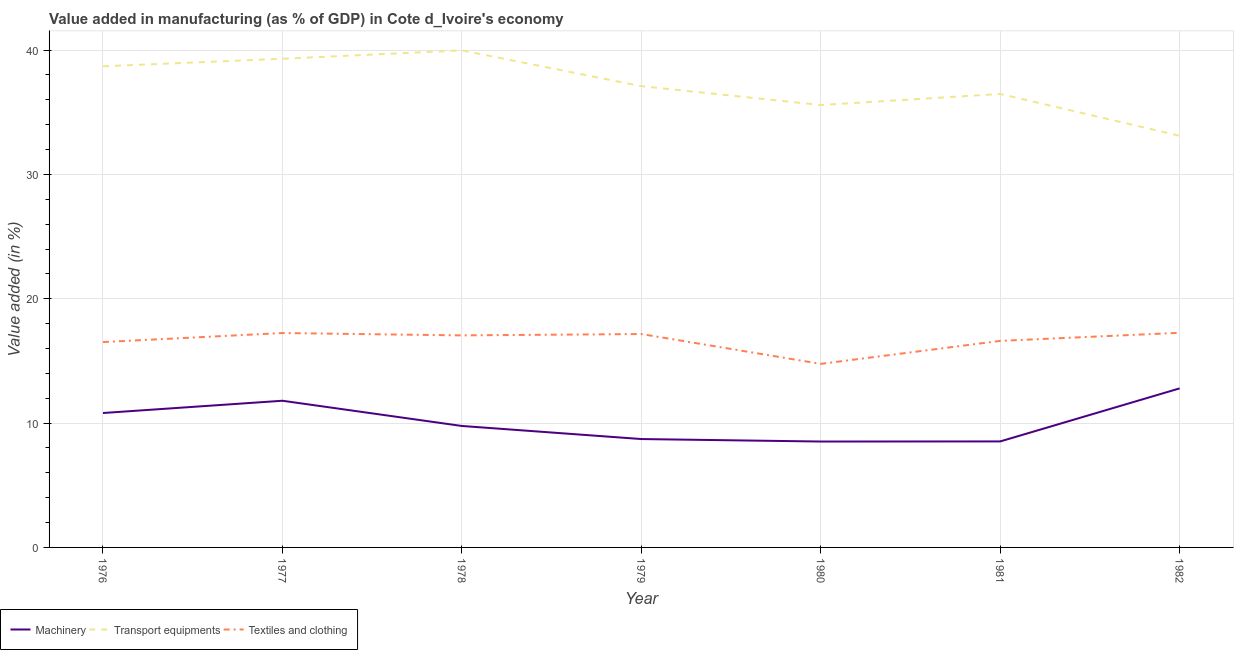Is the number of lines equal to the number of legend labels?
Give a very brief answer. Yes. What is the value added in manufacturing textile and clothing in 1982?
Your answer should be very brief. 17.26. Across all years, what is the maximum value added in manufacturing textile and clothing?
Provide a short and direct response. 17.26. Across all years, what is the minimum value added in manufacturing textile and clothing?
Your answer should be compact. 14.76. In which year was the value added in manufacturing transport equipments maximum?
Provide a short and direct response. 1978. What is the total value added in manufacturing textile and clothing in the graph?
Offer a terse response. 116.62. What is the difference between the value added in manufacturing textile and clothing in 1977 and that in 1978?
Provide a short and direct response. 0.19. What is the difference between the value added in manufacturing transport equipments in 1979 and the value added in manufacturing machinery in 1978?
Your answer should be very brief. 27.33. What is the average value added in manufacturing transport equipments per year?
Offer a very short reply. 37.18. In the year 1979, what is the difference between the value added in manufacturing machinery and value added in manufacturing textile and clothing?
Keep it short and to the point. -8.45. In how many years, is the value added in manufacturing machinery greater than 38 %?
Offer a terse response. 0. What is the ratio of the value added in manufacturing machinery in 1978 to that in 1981?
Provide a short and direct response. 1.15. Is the value added in manufacturing machinery in 1978 less than that in 1980?
Give a very brief answer. No. Is the difference between the value added in manufacturing textile and clothing in 1980 and 1982 greater than the difference between the value added in manufacturing machinery in 1980 and 1982?
Provide a succinct answer. Yes. What is the difference between the highest and the second highest value added in manufacturing machinery?
Your answer should be very brief. 1. What is the difference between the highest and the lowest value added in manufacturing machinery?
Provide a short and direct response. 4.28. In how many years, is the value added in manufacturing transport equipments greater than the average value added in manufacturing transport equipments taken over all years?
Your response must be concise. 3. Is it the case that in every year, the sum of the value added in manufacturing machinery and value added in manufacturing transport equipments is greater than the value added in manufacturing textile and clothing?
Make the answer very short. Yes. Is the value added in manufacturing machinery strictly less than the value added in manufacturing textile and clothing over the years?
Keep it short and to the point. Yes. How many lines are there?
Offer a very short reply. 3. How many years are there in the graph?
Your response must be concise. 7. What is the difference between two consecutive major ticks on the Y-axis?
Keep it short and to the point. 10. Are the values on the major ticks of Y-axis written in scientific E-notation?
Provide a short and direct response. No. Does the graph contain any zero values?
Provide a short and direct response. No. Does the graph contain grids?
Your answer should be compact. Yes. Where does the legend appear in the graph?
Your answer should be compact. Bottom left. How are the legend labels stacked?
Provide a succinct answer. Horizontal. What is the title of the graph?
Give a very brief answer. Value added in manufacturing (as % of GDP) in Cote d_Ivoire's economy. Does "Tertiary" appear as one of the legend labels in the graph?
Give a very brief answer. No. What is the label or title of the Y-axis?
Offer a terse response. Value added (in %). What is the Value added (in %) of Machinery in 1976?
Offer a very short reply. 10.81. What is the Value added (in %) of Transport equipments in 1976?
Give a very brief answer. 38.7. What is the Value added (in %) of Textiles and clothing in 1976?
Ensure brevity in your answer.  16.52. What is the Value added (in %) in Machinery in 1977?
Offer a terse response. 11.8. What is the Value added (in %) of Transport equipments in 1977?
Your answer should be compact. 39.31. What is the Value added (in %) of Textiles and clothing in 1977?
Your answer should be compact. 17.25. What is the Value added (in %) in Machinery in 1978?
Offer a very short reply. 9.77. What is the Value added (in %) of Transport equipments in 1978?
Ensure brevity in your answer.  39.98. What is the Value added (in %) in Textiles and clothing in 1978?
Offer a terse response. 17.05. What is the Value added (in %) in Machinery in 1979?
Offer a terse response. 8.72. What is the Value added (in %) of Transport equipments in 1979?
Your answer should be compact. 37.1. What is the Value added (in %) in Textiles and clothing in 1979?
Give a very brief answer. 17.16. What is the Value added (in %) in Machinery in 1980?
Give a very brief answer. 8.52. What is the Value added (in %) in Transport equipments in 1980?
Offer a very short reply. 35.58. What is the Value added (in %) in Textiles and clothing in 1980?
Keep it short and to the point. 14.76. What is the Value added (in %) in Machinery in 1981?
Your answer should be compact. 8.53. What is the Value added (in %) of Transport equipments in 1981?
Provide a succinct answer. 36.48. What is the Value added (in %) in Textiles and clothing in 1981?
Provide a short and direct response. 16.61. What is the Value added (in %) in Machinery in 1982?
Your answer should be very brief. 12.79. What is the Value added (in %) in Transport equipments in 1982?
Make the answer very short. 33.11. What is the Value added (in %) in Textiles and clothing in 1982?
Provide a succinct answer. 17.26. Across all years, what is the maximum Value added (in %) in Machinery?
Your answer should be compact. 12.79. Across all years, what is the maximum Value added (in %) in Transport equipments?
Keep it short and to the point. 39.98. Across all years, what is the maximum Value added (in %) of Textiles and clothing?
Your response must be concise. 17.26. Across all years, what is the minimum Value added (in %) in Machinery?
Your answer should be compact. 8.52. Across all years, what is the minimum Value added (in %) of Transport equipments?
Provide a short and direct response. 33.11. Across all years, what is the minimum Value added (in %) of Textiles and clothing?
Ensure brevity in your answer.  14.76. What is the total Value added (in %) in Machinery in the graph?
Your response must be concise. 70.93. What is the total Value added (in %) of Transport equipments in the graph?
Offer a terse response. 260.26. What is the total Value added (in %) in Textiles and clothing in the graph?
Provide a short and direct response. 116.62. What is the difference between the Value added (in %) of Machinery in 1976 and that in 1977?
Your answer should be very brief. -0.99. What is the difference between the Value added (in %) of Transport equipments in 1976 and that in 1977?
Your response must be concise. -0.61. What is the difference between the Value added (in %) of Textiles and clothing in 1976 and that in 1977?
Provide a succinct answer. -0.73. What is the difference between the Value added (in %) of Machinery in 1976 and that in 1978?
Your answer should be very brief. 1.04. What is the difference between the Value added (in %) of Transport equipments in 1976 and that in 1978?
Offer a very short reply. -1.28. What is the difference between the Value added (in %) of Textiles and clothing in 1976 and that in 1978?
Provide a short and direct response. -0.54. What is the difference between the Value added (in %) of Machinery in 1976 and that in 1979?
Your response must be concise. 2.09. What is the difference between the Value added (in %) of Transport equipments in 1976 and that in 1979?
Offer a very short reply. 1.6. What is the difference between the Value added (in %) of Textiles and clothing in 1976 and that in 1979?
Make the answer very short. -0.65. What is the difference between the Value added (in %) of Machinery in 1976 and that in 1980?
Make the answer very short. 2.29. What is the difference between the Value added (in %) of Transport equipments in 1976 and that in 1980?
Ensure brevity in your answer.  3.11. What is the difference between the Value added (in %) in Textiles and clothing in 1976 and that in 1980?
Make the answer very short. 1.75. What is the difference between the Value added (in %) of Machinery in 1976 and that in 1981?
Your response must be concise. 2.29. What is the difference between the Value added (in %) in Transport equipments in 1976 and that in 1981?
Give a very brief answer. 2.22. What is the difference between the Value added (in %) in Textiles and clothing in 1976 and that in 1981?
Provide a short and direct response. -0.1. What is the difference between the Value added (in %) of Machinery in 1976 and that in 1982?
Provide a short and direct response. -1.98. What is the difference between the Value added (in %) in Transport equipments in 1976 and that in 1982?
Make the answer very short. 5.59. What is the difference between the Value added (in %) in Textiles and clothing in 1976 and that in 1982?
Your response must be concise. -0.75. What is the difference between the Value added (in %) of Machinery in 1977 and that in 1978?
Provide a succinct answer. 2.03. What is the difference between the Value added (in %) in Transport equipments in 1977 and that in 1978?
Make the answer very short. -0.67. What is the difference between the Value added (in %) of Textiles and clothing in 1977 and that in 1978?
Offer a very short reply. 0.19. What is the difference between the Value added (in %) in Machinery in 1977 and that in 1979?
Your answer should be compact. 3.08. What is the difference between the Value added (in %) of Transport equipments in 1977 and that in 1979?
Provide a succinct answer. 2.2. What is the difference between the Value added (in %) in Textiles and clothing in 1977 and that in 1979?
Ensure brevity in your answer.  0.08. What is the difference between the Value added (in %) of Machinery in 1977 and that in 1980?
Make the answer very short. 3.28. What is the difference between the Value added (in %) in Transport equipments in 1977 and that in 1980?
Give a very brief answer. 3.72. What is the difference between the Value added (in %) of Textiles and clothing in 1977 and that in 1980?
Provide a succinct answer. 2.48. What is the difference between the Value added (in %) in Machinery in 1977 and that in 1981?
Your response must be concise. 3.27. What is the difference between the Value added (in %) of Transport equipments in 1977 and that in 1981?
Provide a short and direct response. 2.83. What is the difference between the Value added (in %) in Textiles and clothing in 1977 and that in 1981?
Provide a short and direct response. 0.63. What is the difference between the Value added (in %) of Machinery in 1977 and that in 1982?
Make the answer very short. -1. What is the difference between the Value added (in %) in Transport equipments in 1977 and that in 1982?
Ensure brevity in your answer.  6.2. What is the difference between the Value added (in %) in Textiles and clothing in 1977 and that in 1982?
Provide a succinct answer. -0.02. What is the difference between the Value added (in %) of Machinery in 1978 and that in 1979?
Keep it short and to the point. 1.05. What is the difference between the Value added (in %) in Transport equipments in 1978 and that in 1979?
Your answer should be compact. 2.88. What is the difference between the Value added (in %) in Textiles and clothing in 1978 and that in 1979?
Make the answer very short. -0.11. What is the difference between the Value added (in %) of Machinery in 1978 and that in 1980?
Ensure brevity in your answer.  1.25. What is the difference between the Value added (in %) of Transport equipments in 1978 and that in 1980?
Your response must be concise. 4.39. What is the difference between the Value added (in %) of Textiles and clothing in 1978 and that in 1980?
Offer a very short reply. 2.29. What is the difference between the Value added (in %) in Machinery in 1978 and that in 1981?
Keep it short and to the point. 1.24. What is the difference between the Value added (in %) of Transport equipments in 1978 and that in 1981?
Offer a terse response. 3.5. What is the difference between the Value added (in %) in Textiles and clothing in 1978 and that in 1981?
Provide a succinct answer. 0.44. What is the difference between the Value added (in %) of Machinery in 1978 and that in 1982?
Your answer should be compact. -3.02. What is the difference between the Value added (in %) of Transport equipments in 1978 and that in 1982?
Provide a succinct answer. 6.87. What is the difference between the Value added (in %) of Textiles and clothing in 1978 and that in 1982?
Provide a succinct answer. -0.21. What is the difference between the Value added (in %) in Machinery in 1979 and that in 1980?
Provide a succinct answer. 0.2. What is the difference between the Value added (in %) of Transport equipments in 1979 and that in 1980?
Offer a very short reply. 1.52. What is the difference between the Value added (in %) of Textiles and clothing in 1979 and that in 1980?
Keep it short and to the point. 2.4. What is the difference between the Value added (in %) in Machinery in 1979 and that in 1981?
Give a very brief answer. 0.19. What is the difference between the Value added (in %) in Transport equipments in 1979 and that in 1981?
Your answer should be compact. 0.63. What is the difference between the Value added (in %) of Textiles and clothing in 1979 and that in 1981?
Make the answer very short. 0.55. What is the difference between the Value added (in %) in Machinery in 1979 and that in 1982?
Your answer should be compact. -4.08. What is the difference between the Value added (in %) of Transport equipments in 1979 and that in 1982?
Provide a succinct answer. 3.99. What is the difference between the Value added (in %) in Textiles and clothing in 1979 and that in 1982?
Give a very brief answer. -0.1. What is the difference between the Value added (in %) of Machinery in 1980 and that in 1981?
Offer a very short reply. -0.01. What is the difference between the Value added (in %) of Transport equipments in 1980 and that in 1981?
Make the answer very short. -0.89. What is the difference between the Value added (in %) in Textiles and clothing in 1980 and that in 1981?
Give a very brief answer. -1.85. What is the difference between the Value added (in %) in Machinery in 1980 and that in 1982?
Your response must be concise. -4.28. What is the difference between the Value added (in %) in Transport equipments in 1980 and that in 1982?
Offer a very short reply. 2.47. What is the difference between the Value added (in %) in Textiles and clothing in 1980 and that in 1982?
Provide a short and direct response. -2.5. What is the difference between the Value added (in %) of Machinery in 1981 and that in 1982?
Offer a terse response. -4.27. What is the difference between the Value added (in %) in Transport equipments in 1981 and that in 1982?
Your answer should be compact. 3.36. What is the difference between the Value added (in %) of Textiles and clothing in 1981 and that in 1982?
Make the answer very short. -0.65. What is the difference between the Value added (in %) in Machinery in 1976 and the Value added (in %) in Transport equipments in 1977?
Make the answer very short. -28.49. What is the difference between the Value added (in %) in Machinery in 1976 and the Value added (in %) in Textiles and clothing in 1977?
Ensure brevity in your answer.  -6.43. What is the difference between the Value added (in %) in Transport equipments in 1976 and the Value added (in %) in Textiles and clothing in 1977?
Keep it short and to the point. 21.45. What is the difference between the Value added (in %) in Machinery in 1976 and the Value added (in %) in Transport equipments in 1978?
Give a very brief answer. -29.17. What is the difference between the Value added (in %) of Machinery in 1976 and the Value added (in %) of Textiles and clothing in 1978?
Offer a very short reply. -6.24. What is the difference between the Value added (in %) of Transport equipments in 1976 and the Value added (in %) of Textiles and clothing in 1978?
Offer a very short reply. 21.64. What is the difference between the Value added (in %) of Machinery in 1976 and the Value added (in %) of Transport equipments in 1979?
Your answer should be very brief. -26.29. What is the difference between the Value added (in %) in Machinery in 1976 and the Value added (in %) in Textiles and clothing in 1979?
Your answer should be compact. -6.35. What is the difference between the Value added (in %) in Transport equipments in 1976 and the Value added (in %) in Textiles and clothing in 1979?
Provide a short and direct response. 21.54. What is the difference between the Value added (in %) of Machinery in 1976 and the Value added (in %) of Transport equipments in 1980?
Keep it short and to the point. -24.77. What is the difference between the Value added (in %) in Machinery in 1976 and the Value added (in %) in Textiles and clothing in 1980?
Offer a very short reply. -3.95. What is the difference between the Value added (in %) of Transport equipments in 1976 and the Value added (in %) of Textiles and clothing in 1980?
Ensure brevity in your answer.  23.94. What is the difference between the Value added (in %) of Machinery in 1976 and the Value added (in %) of Transport equipments in 1981?
Offer a terse response. -25.66. What is the difference between the Value added (in %) in Machinery in 1976 and the Value added (in %) in Textiles and clothing in 1981?
Keep it short and to the point. -5.8. What is the difference between the Value added (in %) of Transport equipments in 1976 and the Value added (in %) of Textiles and clothing in 1981?
Your answer should be compact. 22.09. What is the difference between the Value added (in %) in Machinery in 1976 and the Value added (in %) in Transport equipments in 1982?
Your response must be concise. -22.3. What is the difference between the Value added (in %) in Machinery in 1976 and the Value added (in %) in Textiles and clothing in 1982?
Make the answer very short. -6.45. What is the difference between the Value added (in %) of Transport equipments in 1976 and the Value added (in %) of Textiles and clothing in 1982?
Provide a succinct answer. 21.44. What is the difference between the Value added (in %) of Machinery in 1977 and the Value added (in %) of Transport equipments in 1978?
Provide a short and direct response. -28.18. What is the difference between the Value added (in %) in Machinery in 1977 and the Value added (in %) in Textiles and clothing in 1978?
Offer a terse response. -5.26. What is the difference between the Value added (in %) of Transport equipments in 1977 and the Value added (in %) of Textiles and clothing in 1978?
Your answer should be very brief. 22.25. What is the difference between the Value added (in %) of Machinery in 1977 and the Value added (in %) of Transport equipments in 1979?
Your response must be concise. -25.31. What is the difference between the Value added (in %) in Machinery in 1977 and the Value added (in %) in Textiles and clothing in 1979?
Keep it short and to the point. -5.37. What is the difference between the Value added (in %) of Transport equipments in 1977 and the Value added (in %) of Textiles and clothing in 1979?
Make the answer very short. 22.14. What is the difference between the Value added (in %) of Machinery in 1977 and the Value added (in %) of Transport equipments in 1980?
Make the answer very short. -23.79. What is the difference between the Value added (in %) of Machinery in 1977 and the Value added (in %) of Textiles and clothing in 1980?
Provide a short and direct response. -2.97. What is the difference between the Value added (in %) in Transport equipments in 1977 and the Value added (in %) in Textiles and clothing in 1980?
Keep it short and to the point. 24.54. What is the difference between the Value added (in %) in Machinery in 1977 and the Value added (in %) in Transport equipments in 1981?
Your answer should be very brief. -24.68. What is the difference between the Value added (in %) of Machinery in 1977 and the Value added (in %) of Textiles and clothing in 1981?
Give a very brief answer. -4.82. What is the difference between the Value added (in %) of Transport equipments in 1977 and the Value added (in %) of Textiles and clothing in 1981?
Your answer should be very brief. 22.69. What is the difference between the Value added (in %) in Machinery in 1977 and the Value added (in %) in Transport equipments in 1982?
Your answer should be compact. -21.31. What is the difference between the Value added (in %) of Machinery in 1977 and the Value added (in %) of Textiles and clothing in 1982?
Offer a terse response. -5.47. What is the difference between the Value added (in %) of Transport equipments in 1977 and the Value added (in %) of Textiles and clothing in 1982?
Provide a succinct answer. 22.04. What is the difference between the Value added (in %) of Machinery in 1978 and the Value added (in %) of Transport equipments in 1979?
Your answer should be very brief. -27.33. What is the difference between the Value added (in %) in Machinery in 1978 and the Value added (in %) in Textiles and clothing in 1979?
Ensure brevity in your answer.  -7.39. What is the difference between the Value added (in %) of Transport equipments in 1978 and the Value added (in %) of Textiles and clothing in 1979?
Your answer should be very brief. 22.82. What is the difference between the Value added (in %) in Machinery in 1978 and the Value added (in %) in Transport equipments in 1980?
Ensure brevity in your answer.  -25.82. What is the difference between the Value added (in %) of Machinery in 1978 and the Value added (in %) of Textiles and clothing in 1980?
Offer a terse response. -4.99. What is the difference between the Value added (in %) in Transport equipments in 1978 and the Value added (in %) in Textiles and clothing in 1980?
Your response must be concise. 25.22. What is the difference between the Value added (in %) of Machinery in 1978 and the Value added (in %) of Transport equipments in 1981?
Offer a terse response. -26.71. What is the difference between the Value added (in %) of Machinery in 1978 and the Value added (in %) of Textiles and clothing in 1981?
Make the answer very short. -6.84. What is the difference between the Value added (in %) of Transport equipments in 1978 and the Value added (in %) of Textiles and clothing in 1981?
Offer a terse response. 23.37. What is the difference between the Value added (in %) of Machinery in 1978 and the Value added (in %) of Transport equipments in 1982?
Give a very brief answer. -23.34. What is the difference between the Value added (in %) in Machinery in 1978 and the Value added (in %) in Textiles and clothing in 1982?
Offer a terse response. -7.49. What is the difference between the Value added (in %) in Transport equipments in 1978 and the Value added (in %) in Textiles and clothing in 1982?
Provide a short and direct response. 22.72. What is the difference between the Value added (in %) of Machinery in 1979 and the Value added (in %) of Transport equipments in 1980?
Your response must be concise. -26.87. What is the difference between the Value added (in %) of Machinery in 1979 and the Value added (in %) of Textiles and clothing in 1980?
Offer a very short reply. -6.05. What is the difference between the Value added (in %) of Transport equipments in 1979 and the Value added (in %) of Textiles and clothing in 1980?
Offer a terse response. 22.34. What is the difference between the Value added (in %) of Machinery in 1979 and the Value added (in %) of Transport equipments in 1981?
Your response must be concise. -27.76. What is the difference between the Value added (in %) in Machinery in 1979 and the Value added (in %) in Textiles and clothing in 1981?
Keep it short and to the point. -7.9. What is the difference between the Value added (in %) of Transport equipments in 1979 and the Value added (in %) of Textiles and clothing in 1981?
Provide a succinct answer. 20.49. What is the difference between the Value added (in %) of Machinery in 1979 and the Value added (in %) of Transport equipments in 1982?
Your response must be concise. -24.39. What is the difference between the Value added (in %) of Machinery in 1979 and the Value added (in %) of Textiles and clothing in 1982?
Offer a very short reply. -8.55. What is the difference between the Value added (in %) in Transport equipments in 1979 and the Value added (in %) in Textiles and clothing in 1982?
Offer a very short reply. 19.84. What is the difference between the Value added (in %) of Machinery in 1980 and the Value added (in %) of Transport equipments in 1981?
Ensure brevity in your answer.  -27.96. What is the difference between the Value added (in %) of Machinery in 1980 and the Value added (in %) of Textiles and clothing in 1981?
Make the answer very short. -8.1. What is the difference between the Value added (in %) of Transport equipments in 1980 and the Value added (in %) of Textiles and clothing in 1981?
Provide a short and direct response. 18.97. What is the difference between the Value added (in %) in Machinery in 1980 and the Value added (in %) in Transport equipments in 1982?
Ensure brevity in your answer.  -24.59. What is the difference between the Value added (in %) of Machinery in 1980 and the Value added (in %) of Textiles and clothing in 1982?
Make the answer very short. -8.75. What is the difference between the Value added (in %) in Transport equipments in 1980 and the Value added (in %) in Textiles and clothing in 1982?
Make the answer very short. 18.32. What is the difference between the Value added (in %) in Machinery in 1981 and the Value added (in %) in Transport equipments in 1982?
Provide a succinct answer. -24.58. What is the difference between the Value added (in %) in Machinery in 1981 and the Value added (in %) in Textiles and clothing in 1982?
Provide a succinct answer. -8.74. What is the difference between the Value added (in %) of Transport equipments in 1981 and the Value added (in %) of Textiles and clothing in 1982?
Provide a succinct answer. 19.21. What is the average Value added (in %) of Machinery per year?
Give a very brief answer. 10.13. What is the average Value added (in %) of Transport equipments per year?
Provide a short and direct response. 37.18. What is the average Value added (in %) in Textiles and clothing per year?
Offer a very short reply. 16.66. In the year 1976, what is the difference between the Value added (in %) of Machinery and Value added (in %) of Transport equipments?
Give a very brief answer. -27.89. In the year 1976, what is the difference between the Value added (in %) of Machinery and Value added (in %) of Textiles and clothing?
Give a very brief answer. -5.71. In the year 1976, what is the difference between the Value added (in %) of Transport equipments and Value added (in %) of Textiles and clothing?
Provide a succinct answer. 22.18. In the year 1977, what is the difference between the Value added (in %) of Machinery and Value added (in %) of Transport equipments?
Your answer should be compact. -27.51. In the year 1977, what is the difference between the Value added (in %) of Machinery and Value added (in %) of Textiles and clothing?
Your answer should be compact. -5.45. In the year 1977, what is the difference between the Value added (in %) of Transport equipments and Value added (in %) of Textiles and clothing?
Ensure brevity in your answer.  22.06. In the year 1978, what is the difference between the Value added (in %) of Machinery and Value added (in %) of Transport equipments?
Your response must be concise. -30.21. In the year 1978, what is the difference between the Value added (in %) of Machinery and Value added (in %) of Textiles and clothing?
Make the answer very short. -7.29. In the year 1978, what is the difference between the Value added (in %) in Transport equipments and Value added (in %) in Textiles and clothing?
Your response must be concise. 22.92. In the year 1979, what is the difference between the Value added (in %) in Machinery and Value added (in %) in Transport equipments?
Offer a terse response. -28.39. In the year 1979, what is the difference between the Value added (in %) in Machinery and Value added (in %) in Textiles and clothing?
Give a very brief answer. -8.45. In the year 1979, what is the difference between the Value added (in %) of Transport equipments and Value added (in %) of Textiles and clothing?
Provide a succinct answer. 19.94. In the year 1980, what is the difference between the Value added (in %) in Machinery and Value added (in %) in Transport equipments?
Ensure brevity in your answer.  -27.07. In the year 1980, what is the difference between the Value added (in %) of Machinery and Value added (in %) of Textiles and clothing?
Your response must be concise. -6.25. In the year 1980, what is the difference between the Value added (in %) in Transport equipments and Value added (in %) in Textiles and clothing?
Offer a terse response. 20.82. In the year 1981, what is the difference between the Value added (in %) in Machinery and Value added (in %) in Transport equipments?
Make the answer very short. -27.95. In the year 1981, what is the difference between the Value added (in %) of Machinery and Value added (in %) of Textiles and clothing?
Your answer should be very brief. -8.09. In the year 1981, what is the difference between the Value added (in %) in Transport equipments and Value added (in %) in Textiles and clothing?
Your answer should be very brief. 19.86. In the year 1982, what is the difference between the Value added (in %) of Machinery and Value added (in %) of Transport equipments?
Give a very brief answer. -20.32. In the year 1982, what is the difference between the Value added (in %) in Machinery and Value added (in %) in Textiles and clothing?
Keep it short and to the point. -4.47. In the year 1982, what is the difference between the Value added (in %) in Transport equipments and Value added (in %) in Textiles and clothing?
Offer a terse response. 15.85. What is the ratio of the Value added (in %) of Machinery in 1976 to that in 1977?
Your response must be concise. 0.92. What is the ratio of the Value added (in %) in Transport equipments in 1976 to that in 1977?
Ensure brevity in your answer.  0.98. What is the ratio of the Value added (in %) of Textiles and clothing in 1976 to that in 1977?
Your response must be concise. 0.96. What is the ratio of the Value added (in %) in Machinery in 1976 to that in 1978?
Your answer should be compact. 1.11. What is the ratio of the Value added (in %) of Textiles and clothing in 1976 to that in 1978?
Your answer should be compact. 0.97. What is the ratio of the Value added (in %) of Machinery in 1976 to that in 1979?
Ensure brevity in your answer.  1.24. What is the ratio of the Value added (in %) in Transport equipments in 1976 to that in 1979?
Provide a short and direct response. 1.04. What is the ratio of the Value added (in %) of Textiles and clothing in 1976 to that in 1979?
Provide a short and direct response. 0.96. What is the ratio of the Value added (in %) of Machinery in 1976 to that in 1980?
Keep it short and to the point. 1.27. What is the ratio of the Value added (in %) of Transport equipments in 1976 to that in 1980?
Make the answer very short. 1.09. What is the ratio of the Value added (in %) of Textiles and clothing in 1976 to that in 1980?
Provide a succinct answer. 1.12. What is the ratio of the Value added (in %) in Machinery in 1976 to that in 1981?
Your response must be concise. 1.27. What is the ratio of the Value added (in %) of Transport equipments in 1976 to that in 1981?
Ensure brevity in your answer.  1.06. What is the ratio of the Value added (in %) in Machinery in 1976 to that in 1982?
Provide a short and direct response. 0.85. What is the ratio of the Value added (in %) of Transport equipments in 1976 to that in 1982?
Offer a terse response. 1.17. What is the ratio of the Value added (in %) of Textiles and clothing in 1976 to that in 1982?
Keep it short and to the point. 0.96. What is the ratio of the Value added (in %) of Machinery in 1977 to that in 1978?
Ensure brevity in your answer.  1.21. What is the ratio of the Value added (in %) in Transport equipments in 1977 to that in 1978?
Make the answer very short. 0.98. What is the ratio of the Value added (in %) of Textiles and clothing in 1977 to that in 1978?
Make the answer very short. 1.01. What is the ratio of the Value added (in %) in Machinery in 1977 to that in 1979?
Your answer should be compact. 1.35. What is the ratio of the Value added (in %) of Transport equipments in 1977 to that in 1979?
Your answer should be compact. 1.06. What is the ratio of the Value added (in %) in Machinery in 1977 to that in 1980?
Give a very brief answer. 1.39. What is the ratio of the Value added (in %) of Transport equipments in 1977 to that in 1980?
Keep it short and to the point. 1.1. What is the ratio of the Value added (in %) of Textiles and clothing in 1977 to that in 1980?
Make the answer very short. 1.17. What is the ratio of the Value added (in %) of Machinery in 1977 to that in 1981?
Ensure brevity in your answer.  1.38. What is the ratio of the Value added (in %) in Transport equipments in 1977 to that in 1981?
Provide a succinct answer. 1.08. What is the ratio of the Value added (in %) of Textiles and clothing in 1977 to that in 1981?
Make the answer very short. 1.04. What is the ratio of the Value added (in %) of Machinery in 1977 to that in 1982?
Offer a very short reply. 0.92. What is the ratio of the Value added (in %) of Transport equipments in 1977 to that in 1982?
Your response must be concise. 1.19. What is the ratio of the Value added (in %) of Textiles and clothing in 1977 to that in 1982?
Your answer should be very brief. 1. What is the ratio of the Value added (in %) in Machinery in 1978 to that in 1979?
Provide a short and direct response. 1.12. What is the ratio of the Value added (in %) in Transport equipments in 1978 to that in 1979?
Offer a terse response. 1.08. What is the ratio of the Value added (in %) in Machinery in 1978 to that in 1980?
Make the answer very short. 1.15. What is the ratio of the Value added (in %) in Transport equipments in 1978 to that in 1980?
Offer a terse response. 1.12. What is the ratio of the Value added (in %) of Textiles and clothing in 1978 to that in 1980?
Provide a succinct answer. 1.16. What is the ratio of the Value added (in %) of Machinery in 1978 to that in 1981?
Your answer should be very brief. 1.15. What is the ratio of the Value added (in %) of Transport equipments in 1978 to that in 1981?
Your answer should be compact. 1.1. What is the ratio of the Value added (in %) of Textiles and clothing in 1978 to that in 1981?
Provide a succinct answer. 1.03. What is the ratio of the Value added (in %) of Machinery in 1978 to that in 1982?
Offer a very short reply. 0.76. What is the ratio of the Value added (in %) of Transport equipments in 1978 to that in 1982?
Your answer should be compact. 1.21. What is the ratio of the Value added (in %) in Textiles and clothing in 1978 to that in 1982?
Your response must be concise. 0.99. What is the ratio of the Value added (in %) of Machinery in 1979 to that in 1980?
Give a very brief answer. 1.02. What is the ratio of the Value added (in %) of Transport equipments in 1979 to that in 1980?
Offer a terse response. 1.04. What is the ratio of the Value added (in %) in Textiles and clothing in 1979 to that in 1980?
Offer a very short reply. 1.16. What is the ratio of the Value added (in %) in Machinery in 1979 to that in 1981?
Offer a terse response. 1.02. What is the ratio of the Value added (in %) of Transport equipments in 1979 to that in 1981?
Make the answer very short. 1.02. What is the ratio of the Value added (in %) in Textiles and clothing in 1979 to that in 1981?
Your response must be concise. 1.03. What is the ratio of the Value added (in %) in Machinery in 1979 to that in 1982?
Give a very brief answer. 0.68. What is the ratio of the Value added (in %) in Transport equipments in 1979 to that in 1982?
Make the answer very short. 1.12. What is the ratio of the Value added (in %) of Textiles and clothing in 1979 to that in 1982?
Offer a terse response. 0.99. What is the ratio of the Value added (in %) of Transport equipments in 1980 to that in 1981?
Give a very brief answer. 0.98. What is the ratio of the Value added (in %) in Textiles and clothing in 1980 to that in 1981?
Your answer should be compact. 0.89. What is the ratio of the Value added (in %) of Machinery in 1980 to that in 1982?
Your answer should be very brief. 0.67. What is the ratio of the Value added (in %) of Transport equipments in 1980 to that in 1982?
Offer a very short reply. 1.07. What is the ratio of the Value added (in %) of Textiles and clothing in 1980 to that in 1982?
Provide a short and direct response. 0.86. What is the ratio of the Value added (in %) in Machinery in 1981 to that in 1982?
Keep it short and to the point. 0.67. What is the ratio of the Value added (in %) of Transport equipments in 1981 to that in 1982?
Your response must be concise. 1.1. What is the ratio of the Value added (in %) of Textiles and clothing in 1981 to that in 1982?
Ensure brevity in your answer.  0.96. What is the difference between the highest and the second highest Value added (in %) of Machinery?
Your answer should be compact. 1. What is the difference between the highest and the second highest Value added (in %) of Transport equipments?
Offer a terse response. 0.67. What is the difference between the highest and the second highest Value added (in %) in Textiles and clothing?
Your answer should be compact. 0.02. What is the difference between the highest and the lowest Value added (in %) in Machinery?
Give a very brief answer. 4.28. What is the difference between the highest and the lowest Value added (in %) in Transport equipments?
Offer a terse response. 6.87. What is the difference between the highest and the lowest Value added (in %) in Textiles and clothing?
Provide a short and direct response. 2.5. 